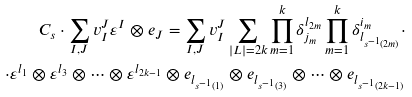<formula> <loc_0><loc_0><loc_500><loc_500>C _ { s } \cdot \sum _ { I , J } v ^ { J } _ { I } \varepsilon ^ { I } \otimes e _ { J } = \sum _ { I , J } v ^ { J } _ { I } \sum _ { | L | = 2 k } \prod _ { m = 1 } ^ { k } \delta ^ { l _ { 2 m } } _ { j _ { m } } \prod _ { m = 1 } ^ { k } \delta ^ { i _ { m } } _ { l _ { s ^ { - 1 } ( 2 m ) } } \cdot \\ \cdot \varepsilon ^ { l _ { 1 } } \otimes \varepsilon ^ { l _ { 3 } } \otimes \dots \otimes \varepsilon ^ { l _ { 2 k - 1 } } \otimes e _ { l _ { s ^ { - 1 } ( 1 ) } } \otimes e _ { l _ { s ^ { - 1 } ( 3 ) } } \otimes \dots \otimes e _ { l _ { s ^ { - 1 } ( 2 k - 1 ) } }</formula> 